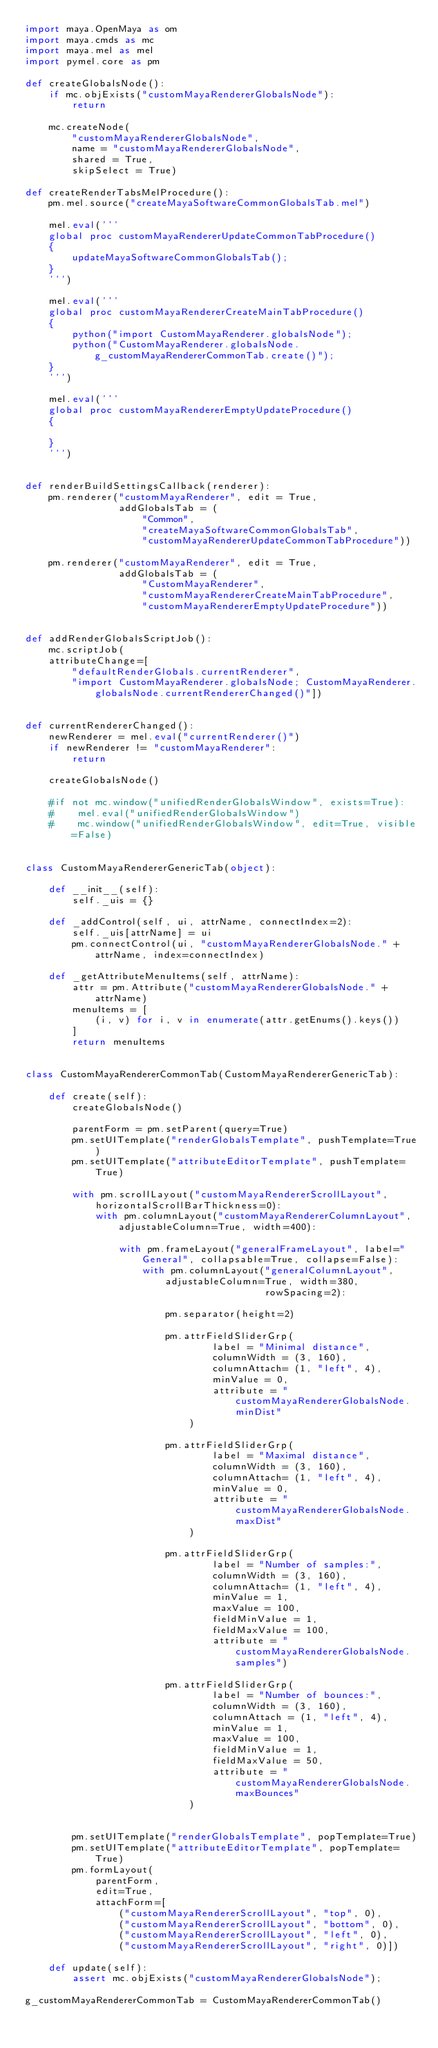Convert code to text. <code><loc_0><loc_0><loc_500><loc_500><_Python_>import maya.OpenMaya as om
import maya.cmds as mc
import maya.mel as mel
import pymel.core as pm

def createGlobalsNode():
    if mc.objExists("customMayaRendererGlobalsNode"):
        return

    mc.createNode(
        "customMayaRendererGlobalsNode",
        name = "customMayaRendererGlobalsNode",
        shared = True,
        skipSelect = True)

def createRenderTabsMelProcedure():
    pm.mel.source("createMayaSoftwareCommonGlobalsTab.mel")

    mel.eval('''
    global proc customMayaRendererUpdateCommonTabProcedure()
    {
        updateMayaSoftwareCommonGlobalsTab();
    }
    ''')

    mel.eval('''
    global proc customMayaRendererCreateMainTabProcedure()
    {
        python("import CustomMayaRenderer.globalsNode");
        python("CustomMayaRenderer.globalsNode.g_customMayaRendererCommonTab.create()");
    }
    ''')

    mel.eval('''
    global proc customMayaRendererEmptyUpdateProcedure()
    {

    }
    ''')


def renderBuildSettingsCallback(renderer):
    pm.renderer("customMayaRenderer", edit = True,
                addGlobalsTab = (
                    "Common",
                    "createMayaSoftwareCommonGlobalsTab",
                    "customMayaRendererUpdateCommonTabProcedure"))

    pm.renderer("customMayaRenderer", edit = True,
                addGlobalsTab = (
                    "CustomMayaRenderer",
                    "customMayaRendererCreateMainTabProcedure",
                    "customMayaRendererEmptyUpdateProcedure"))


def addRenderGlobalsScriptJob():
    mc.scriptJob(
    attributeChange=[
        "defaultRenderGlobals.currentRenderer",
        "import CustomMayaRenderer.globalsNode; CustomMayaRenderer.globalsNode.currentRendererChanged()"])


def currentRendererChanged():
    newRenderer = mel.eval("currentRenderer()")
    if newRenderer != "customMayaRenderer":
        return

    createGlobalsNode()

    #if not mc.window("unifiedRenderGlobalsWindow", exists=True):
    #    mel.eval("unifiedRenderGlobalsWindow")
    #    mc.window("unifiedRenderGlobalsWindow", edit=True, visible=False)


class CustomMayaRendererGenericTab(object):

    def __init__(self):
        self._uis = {}

    def _addControl(self, ui, attrName, connectIndex=2):
        self._uis[attrName] = ui
        pm.connectControl(ui, "customMayaRendererGlobalsNode." + attrName, index=connectIndex)

    def _getAttributeMenuItems(self, attrName):
        attr = pm.Attribute("customMayaRendererGlobalsNode." + attrName)
        menuItems = [
            (i, v) for i, v in enumerate(attr.getEnums().keys())
        ]
        return menuItems


class CustomMayaRendererCommonTab(CustomMayaRendererGenericTab):

    def create(self):
        createGlobalsNode()

        parentForm = pm.setParent(query=True)
        pm.setUITemplate("renderGlobalsTemplate", pushTemplate=True)
        pm.setUITemplate("attributeEditorTemplate", pushTemplate=True)

        with pm.scrollLayout("customMayaRendererScrollLayout", horizontalScrollBarThickness=0):
            with pm.columnLayout("customMayaRendererColumnLayout", adjustableColumn=True, width=400):

                with pm.frameLayout("generalFrameLayout", label="General", collapsable=True, collapse=False):
                    with pm.columnLayout("generalColumnLayout", adjustableColumn=True, width=380,
                                         rowSpacing=2):

                        pm.separator(height=2)

                        pm.attrFieldSliderGrp(
                                label = "Minimal distance",
                                columnWidth = (3, 160),
                                columnAttach= (1, "left", 4),
                                minValue = 0,
                                attribute = "customMayaRendererGlobalsNode.minDist"
                            )

                        pm.attrFieldSliderGrp(
                                label = "Maximal distance",
                                columnWidth = (3, 160),
                                columnAttach= (1, "left", 4),
                                minValue = 0,
                                attribute = "customMayaRendererGlobalsNode.maxDist"
                            )

                        pm.attrFieldSliderGrp(
                                label = "Number of samples:",
                                columnWidth = (3, 160),
                                columnAttach= (1, "left", 4),
                                minValue = 1,
                                maxValue = 100,
                                fieldMinValue = 1,
                                fieldMaxValue = 100,
                                attribute = "customMayaRendererGlobalsNode.samples")

                        pm.attrFieldSliderGrp(
                                label = "Number of bounces:",
                                columnWidth = (3, 160),
                                columnAttach = (1, "left", 4),
                                minValue = 1,
                                maxValue = 100,
                                fieldMinValue = 1,
                                fieldMaxValue = 50,
                                attribute = "customMayaRendererGlobalsNode.maxBounces"
                            )


        pm.setUITemplate("renderGlobalsTemplate", popTemplate=True)
        pm.setUITemplate("attributeEditorTemplate", popTemplate=True)
        pm.formLayout(
            parentForm,
            edit=True,
            attachForm=[
                ("customMayaRendererScrollLayout", "top", 0),
                ("customMayaRendererScrollLayout", "bottom", 0),
                ("customMayaRendererScrollLayout", "left", 0),
                ("customMayaRendererScrollLayout", "right", 0)])

    def update(self):
        assert mc.objExists("customMayaRendererGlobalsNode");

g_customMayaRendererCommonTab = CustomMayaRendererCommonTab()</code> 